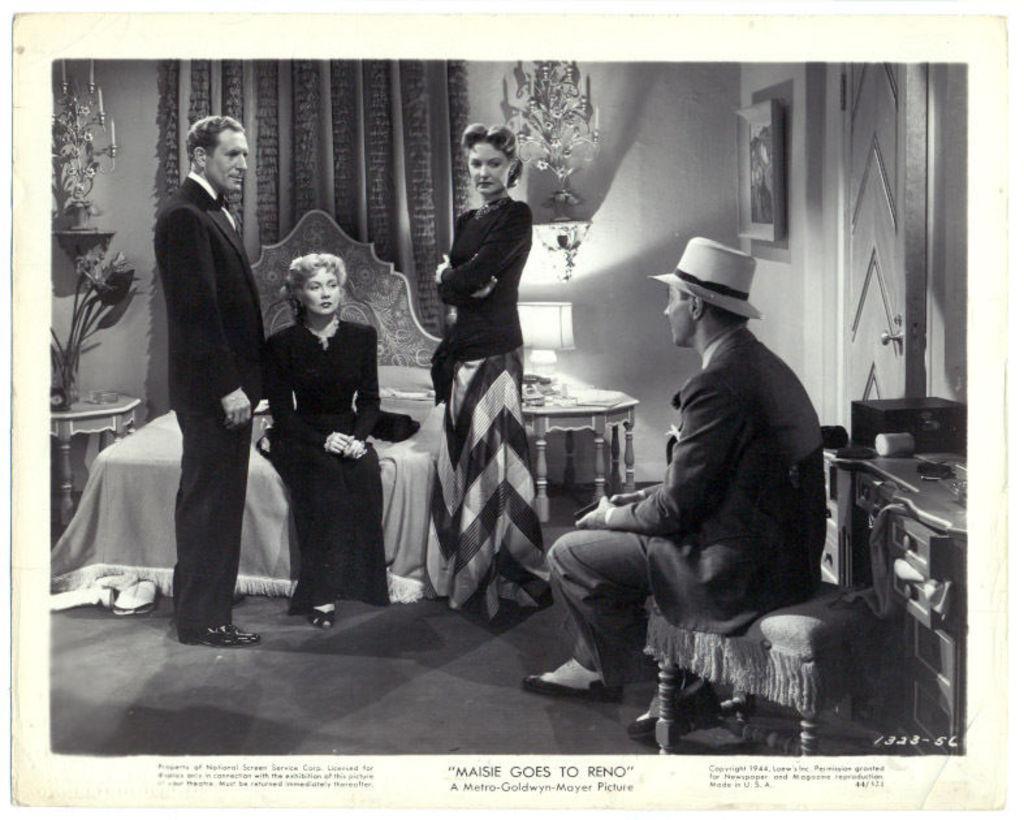Could you give a brief overview of what you see in this image? In this picture I can see an image on the paper, where there are two persons standing, two persons sitting, there are candles with candles stands, there is a bed, a pillow, a door, a stool, a lamp, a frame attached to the wall, there are tables and some other items, there is a watermark on the image and there are some words on the paper. 